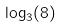Convert formula to latex. <formula><loc_0><loc_0><loc_500><loc_500>\log _ { 3 } ( 8 )</formula> 